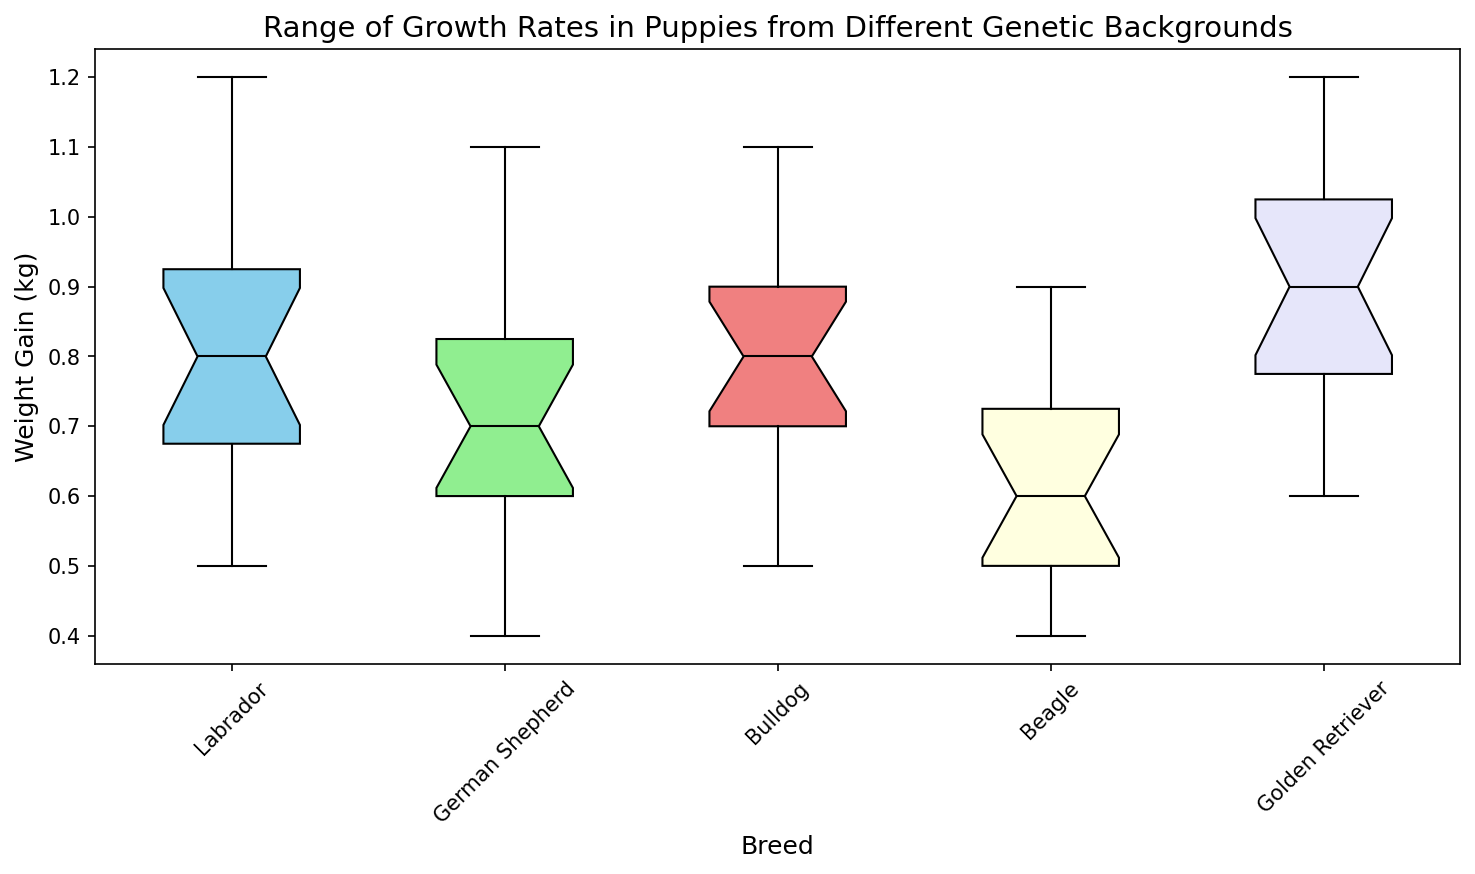What is the median weight gain for Labrador puppies? To find the median weight gain for Labrador puppies, locate the median line inside the box for the "Labrador" category on the box plot. This line represents the median value of the data.
Answer: 0.8 kg Which breed has the widest range of weight gain? The range is determined by the difference between the upper and lower whiskers. Compare the lengths of the whiskers across all breeds. The breed with the longest whiskers will have the widest range.
Answer: Golden Retriever Which breed shows less variation in weight gain, Beagle or Bulldog? Variation is indicated by the interquartile range (IQR), which is the height of the box. Compare the box heights for Beagle and Bulldog. The breed with the shorter box has less variation.
Answer: Beagle What is the interquartile range for German Shepherd puppies' weight gain? The interquartile range (IQR) is the range between the first quartile (bottom of the box) and the third quartile (top of the box). Measure these values for the "German Shepherd" category on the plot.
Answer: Approximately 0.2 kg Which breed has the highest outlier weight gain, and what is its approximate value? Outliers are shown as points outside the whiskers. Identify the breed with the highest outlier point and read its approximate value from the y-axis.
Answer: Golden Retriever, approximately 1.2 kg Are there any breeds that have a median weight gain equal to or greater than 1 kg? To determine this, find the median lines for each breed and check their values. Breeds with median lines equal to or above the 1 kg mark meet the criteria.
Answer: No breed Compare the median weight gains of Labrador and Golden Retriever puppies. Which one is higher? Look at the median lines for both the Labrador and Golden Retriever categories on the box plot. The median line that is higher on the y-axis represents the higher median weight gain.
Answer: Golden Retriever How does the length of the whiskers for Labrador puppies compare to those for Beagle puppies? The whiskers represent the range of the data. Compare the lengths of the whiskers for Labrador and Beagle puppies.
Answer: Labrador whiskers are longer What is the average weight gain for Bulldog puppies? Calculate the mean by summing up all weight gains for Bulldog puppies and dividing by the number of data points (4 weeks x 4 puppies). Sum is 0.7+0.8+0.9+1.0+0.8+0.9+1.0+1.1+0.6+0.7+0.8+0.9+0.5+0.6+0.7+0.8 = 13.4 kg. Average = 13.4/16 ≈ 0.84 kg
Answer: 0.84 kg Which breed has the least extreme minimum weight gain, and what is its value? The minimum weight gain is indicated by the lower whisker. Identify the lowest point for each breed and compare them. The breed with the highest of these minimum points has the least extreme minimum weight gain.
Answer: Golden Retriever, approximately 0.6 kg 